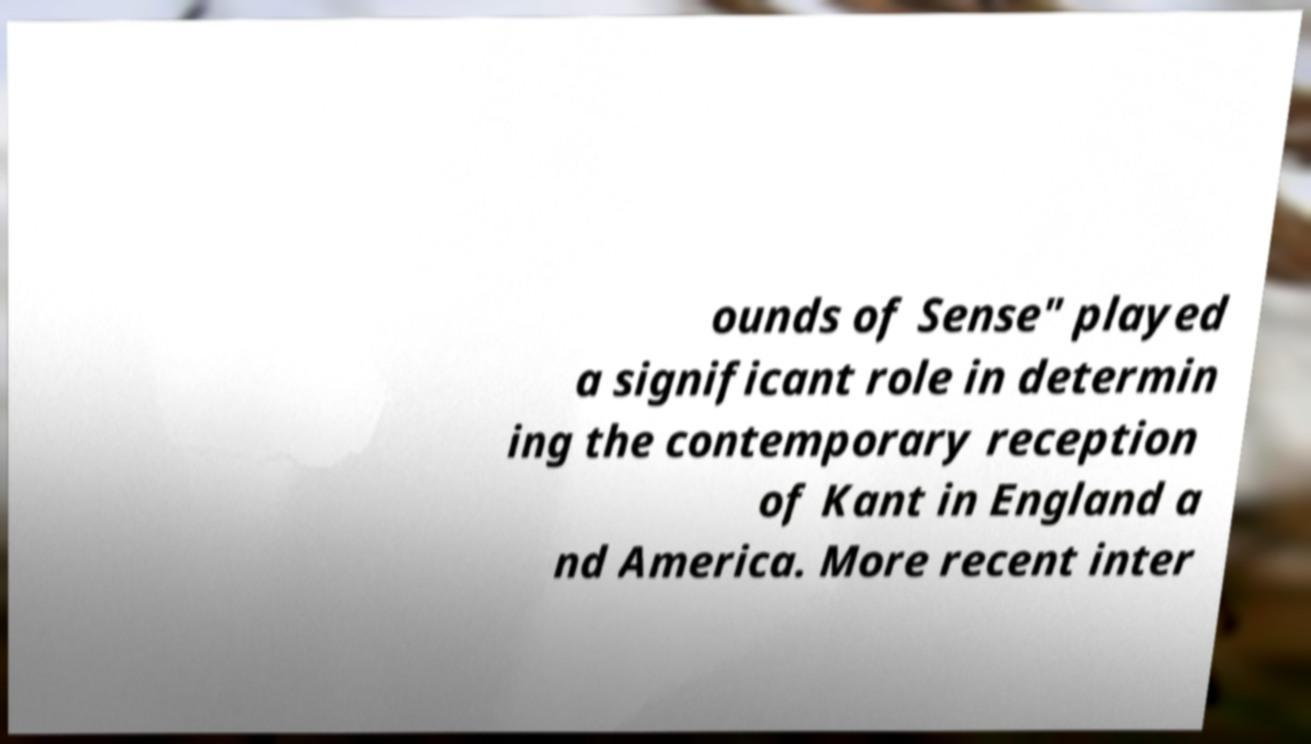Can you read and provide the text displayed in the image?This photo seems to have some interesting text. Can you extract and type it out for me? ounds of Sense" played a significant role in determin ing the contemporary reception of Kant in England a nd America. More recent inter 